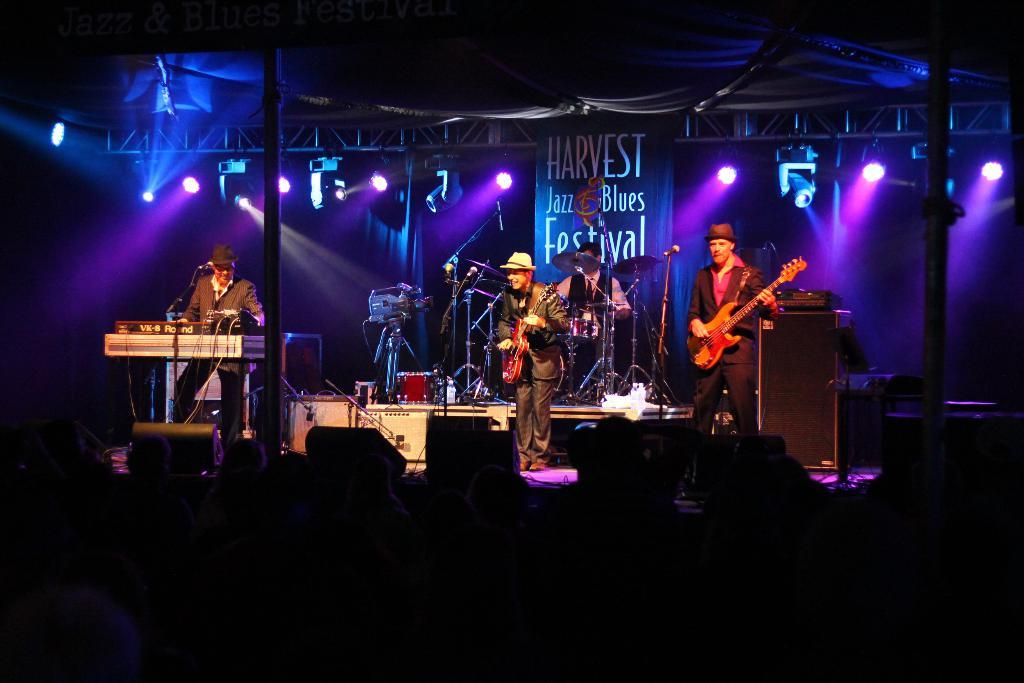What can be seen in the image that provides illumination? There are lights in the image. What is hanging above the stage in the image? There is a banner in the image. How many people are on stage in the image? There are four people on stage in the image. What instruments are being played by the people on stage? Two of the people are holding guitars, and one person is playing musical drums. How does the plane help with the musical performance in the image? There is no plane present in the image; it is a performance on stage with lights, a banner, and people playing musical instruments. What type of teeth can be seen on the people playing instruments in the image? There is no indication of anyone's teeth in the image, as it focuses on the performance and instruments being played. 